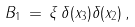<formula> <loc_0><loc_0><loc_500><loc_500>B _ { 1 } \, = \, \xi \, \delta ( x _ { 3 } ) \delta ( x _ { 2 } ) \, ,</formula> 